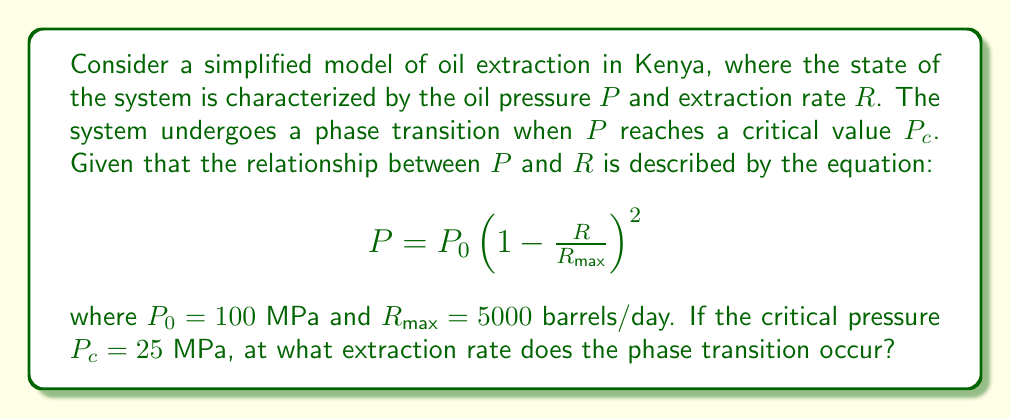Can you solve this math problem? To solve this problem, we'll follow these steps:

1) We know that the phase transition occurs when $P = P_c = 25$ MPa. We need to find the corresponding $R$ value.

2) Substitute the given values into the equation:

   $$25 = 100 \left(1 - \frac{R}{5000}\right)^2$$

3) Simplify the right side:

   $$25 = 100 \left(1 - \frac{R}{5000}\right)^2$$
   $$0.25 = \left(1 - \frac{R}{5000}\right)^2$$

4) Take the square root of both sides:

   $$0.5 = 1 - \frac{R}{5000}$$

5) Subtract 1 from both sides:

   $$-0.5 = -\frac{R}{5000}$$

6) Multiply both sides by -5000:

   $$2500 = R$$

Therefore, the phase transition occurs when the extraction rate $R$ is 2500 barrels/day.
Answer: 2500 barrels/day 